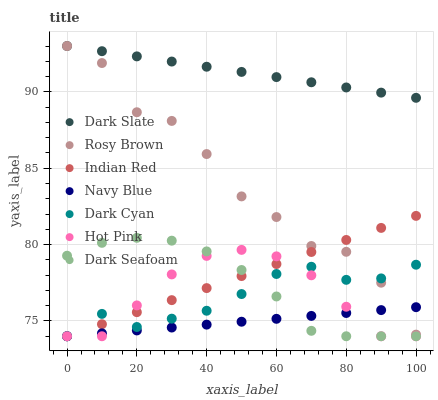Does Navy Blue have the minimum area under the curve?
Answer yes or no. Yes. Does Dark Slate have the maximum area under the curve?
Answer yes or no. Yes. Does Hot Pink have the minimum area under the curve?
Answer yes or no. No. Does Hot Pink have the maximum area under the curve?
Answer yes or no. No. Is Dark Slate the smoothest?
Answer yes or no. Yes. Is Rosy Brown the roughest?
Answer yes or no. Yes. Is Navy Blue the smoothest?
Answer yes or no. No. Is Navy Blue the roughest?
Answer yes or no. No. Does Navy Blue have the lowest value?
Answer yes or no. Yes. Does Dark Slate have the lowest value?
Answer yes or no. No. Does Dark Slate have the highest value?
Answer yes or no. Yes. Does Hot Pink have the highest value?
Answer yes or no. No. Is Dark Cyan less than Dark Slate?
Answer yes or no. Yes. Is Dark Slate greater than Dark Cyan?
Answer yes or no. Yes. Does Rosy Brown intersect Indian Red?
Answer yes or no. Yes. Is Rosy Brown less than Indian Red?
Answer yes or no. No. Is Rosy Brown greater than Indian Red?
Answer yes or no. No. Does Dark Cyan intersect Dark Slate?
Answer yes or no. No. 